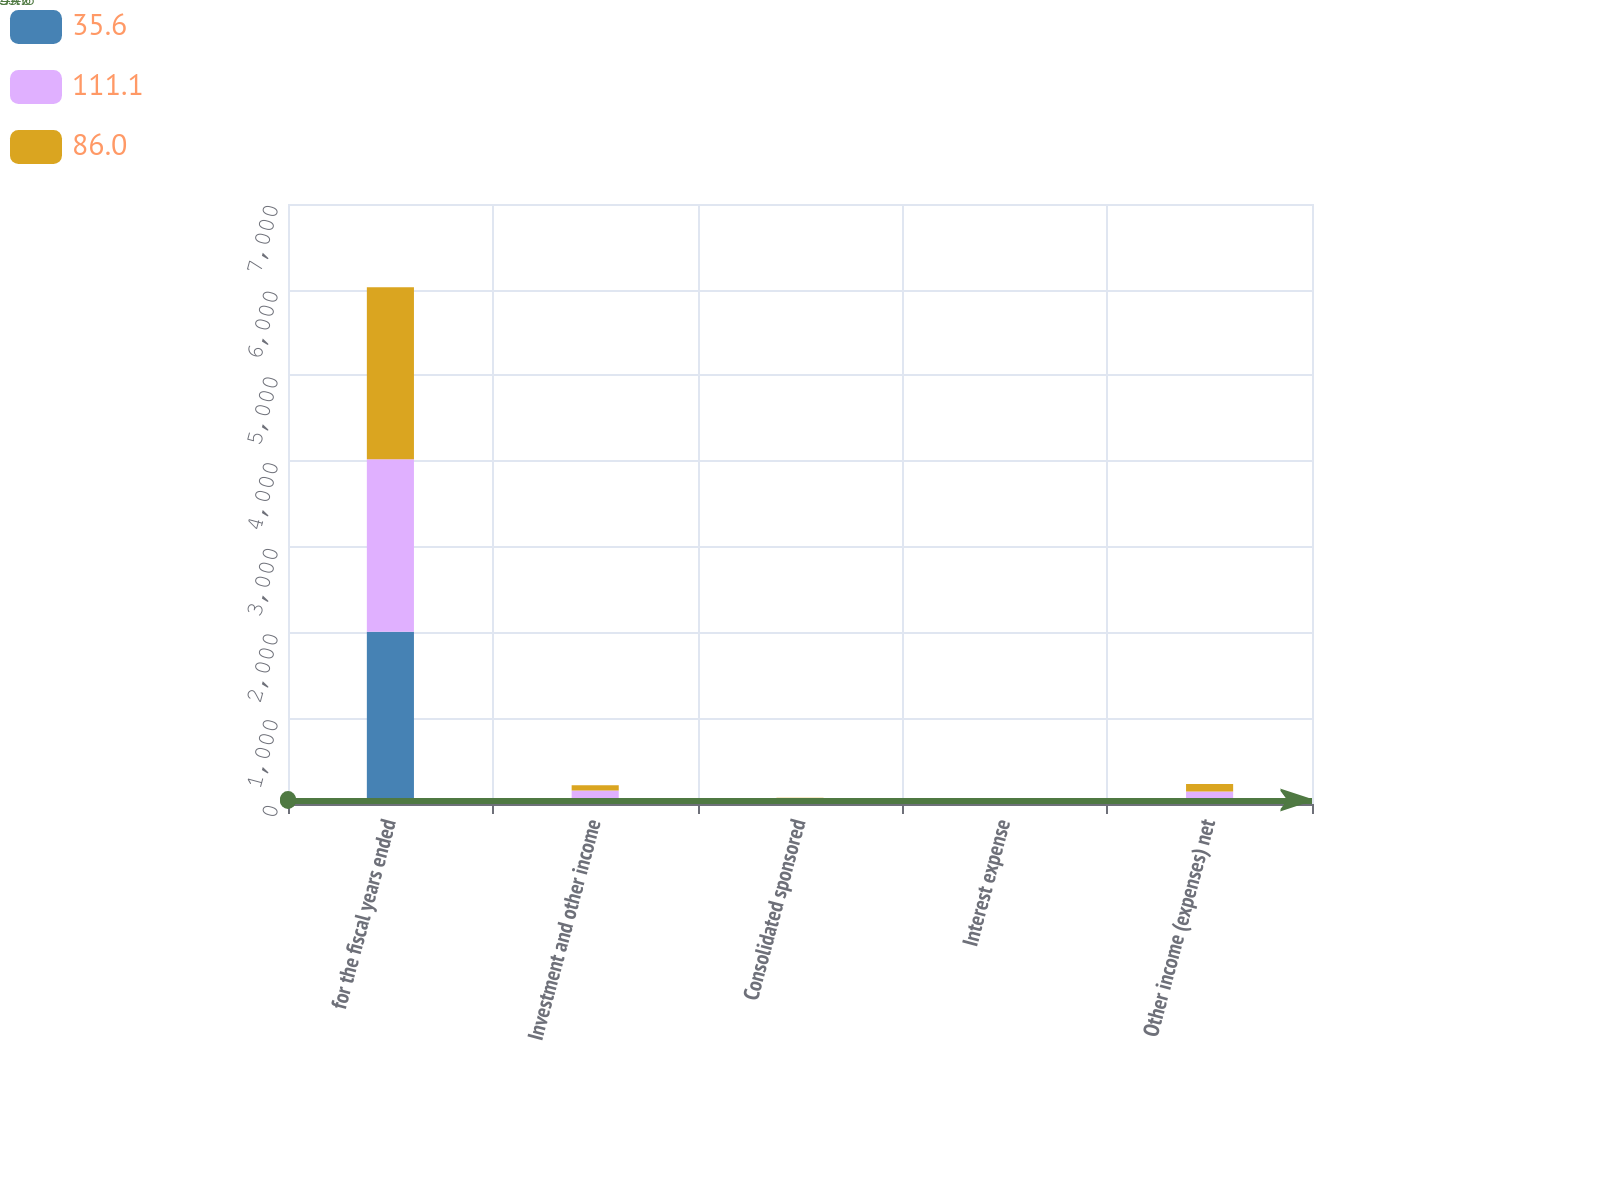<chart> <loc_0><loc_0><loc_500><loc_500><stacked_bar_chart><ecel><fcel>for the fiscal years ended<fcel>Investment and other income<fcel>Consolidated sponsored<fcel>Interest expense<fcel>Other income (expenses) net<nl><fcel>35.6<fcel>2011<fcel>37.9<fcel>36.1<fcel>37.4<fcel>35.6<nl><fcel>111.1<fcel>2010<fcel>119.1<fcel>8.5<fcel>16.5<fcel>111.1<nl><fcel>86<fcel>2009<fcel>61<fcel>28.8<fcel>3.8<fcel>86<nl></chart> 